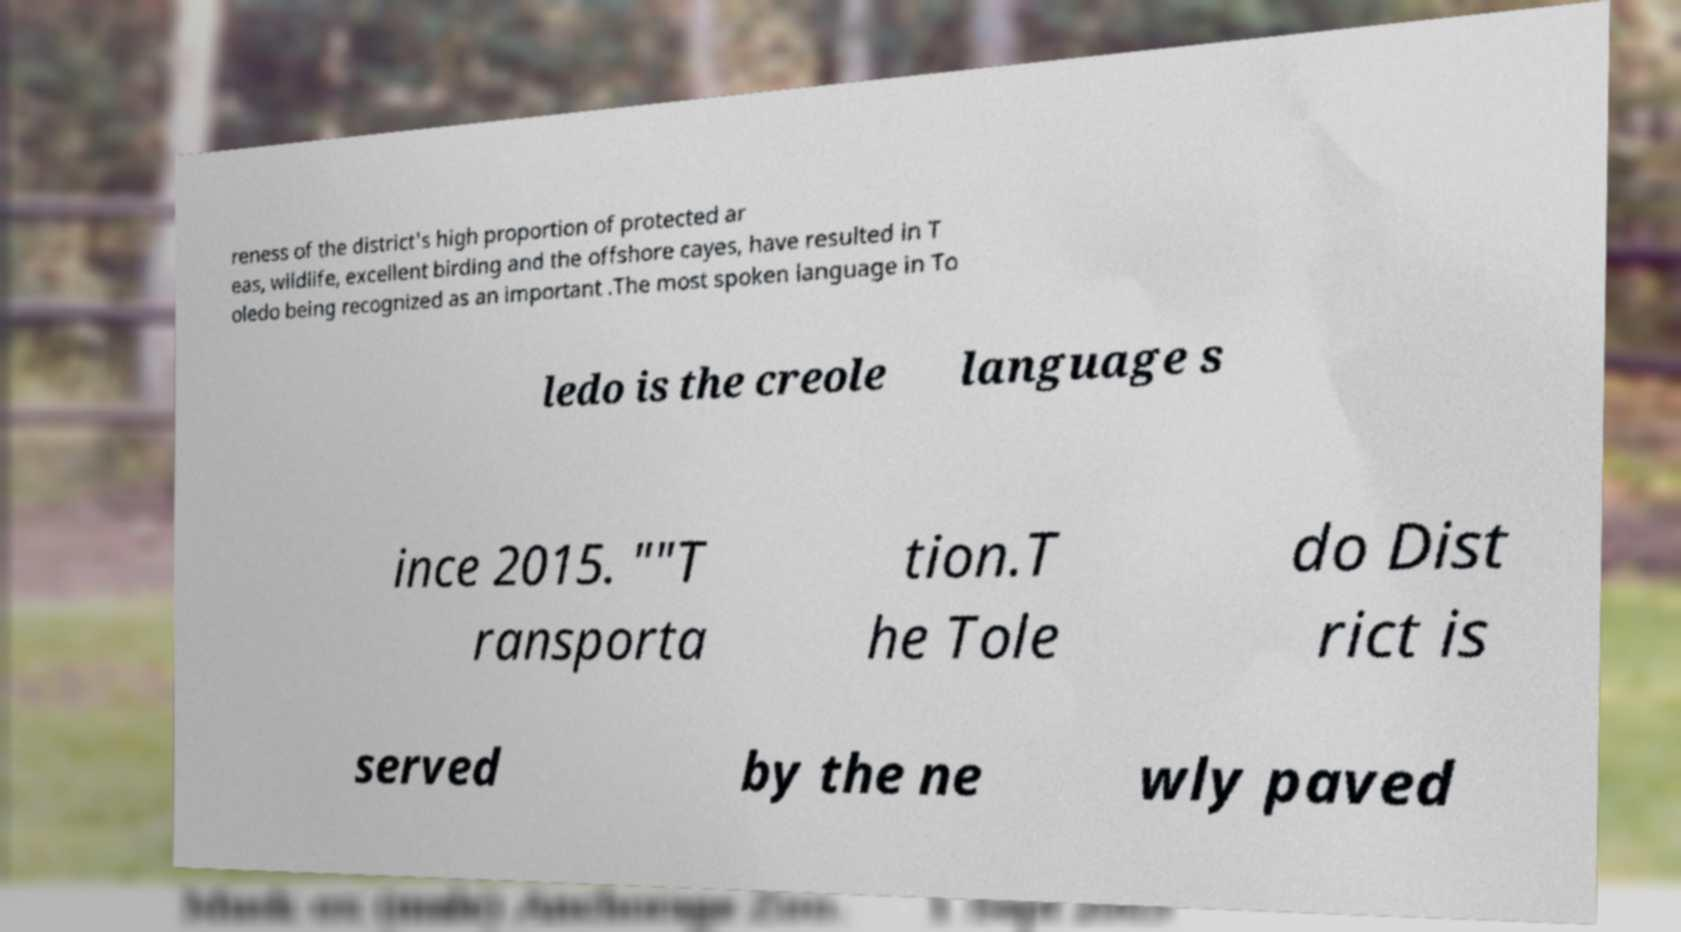What messages or text are displayed in this image? I need them in a readable, typed format. reness of the district's high proportion of protected ar eas, wildlife, excellent birding and the offshore cayes, have resulted in T oledo being recognized as an important .The most spoken language in To ledo is the creole language s ince 2015. ""T ransporta tion.T he Tole do Dist rict is served by the ne wly paved 